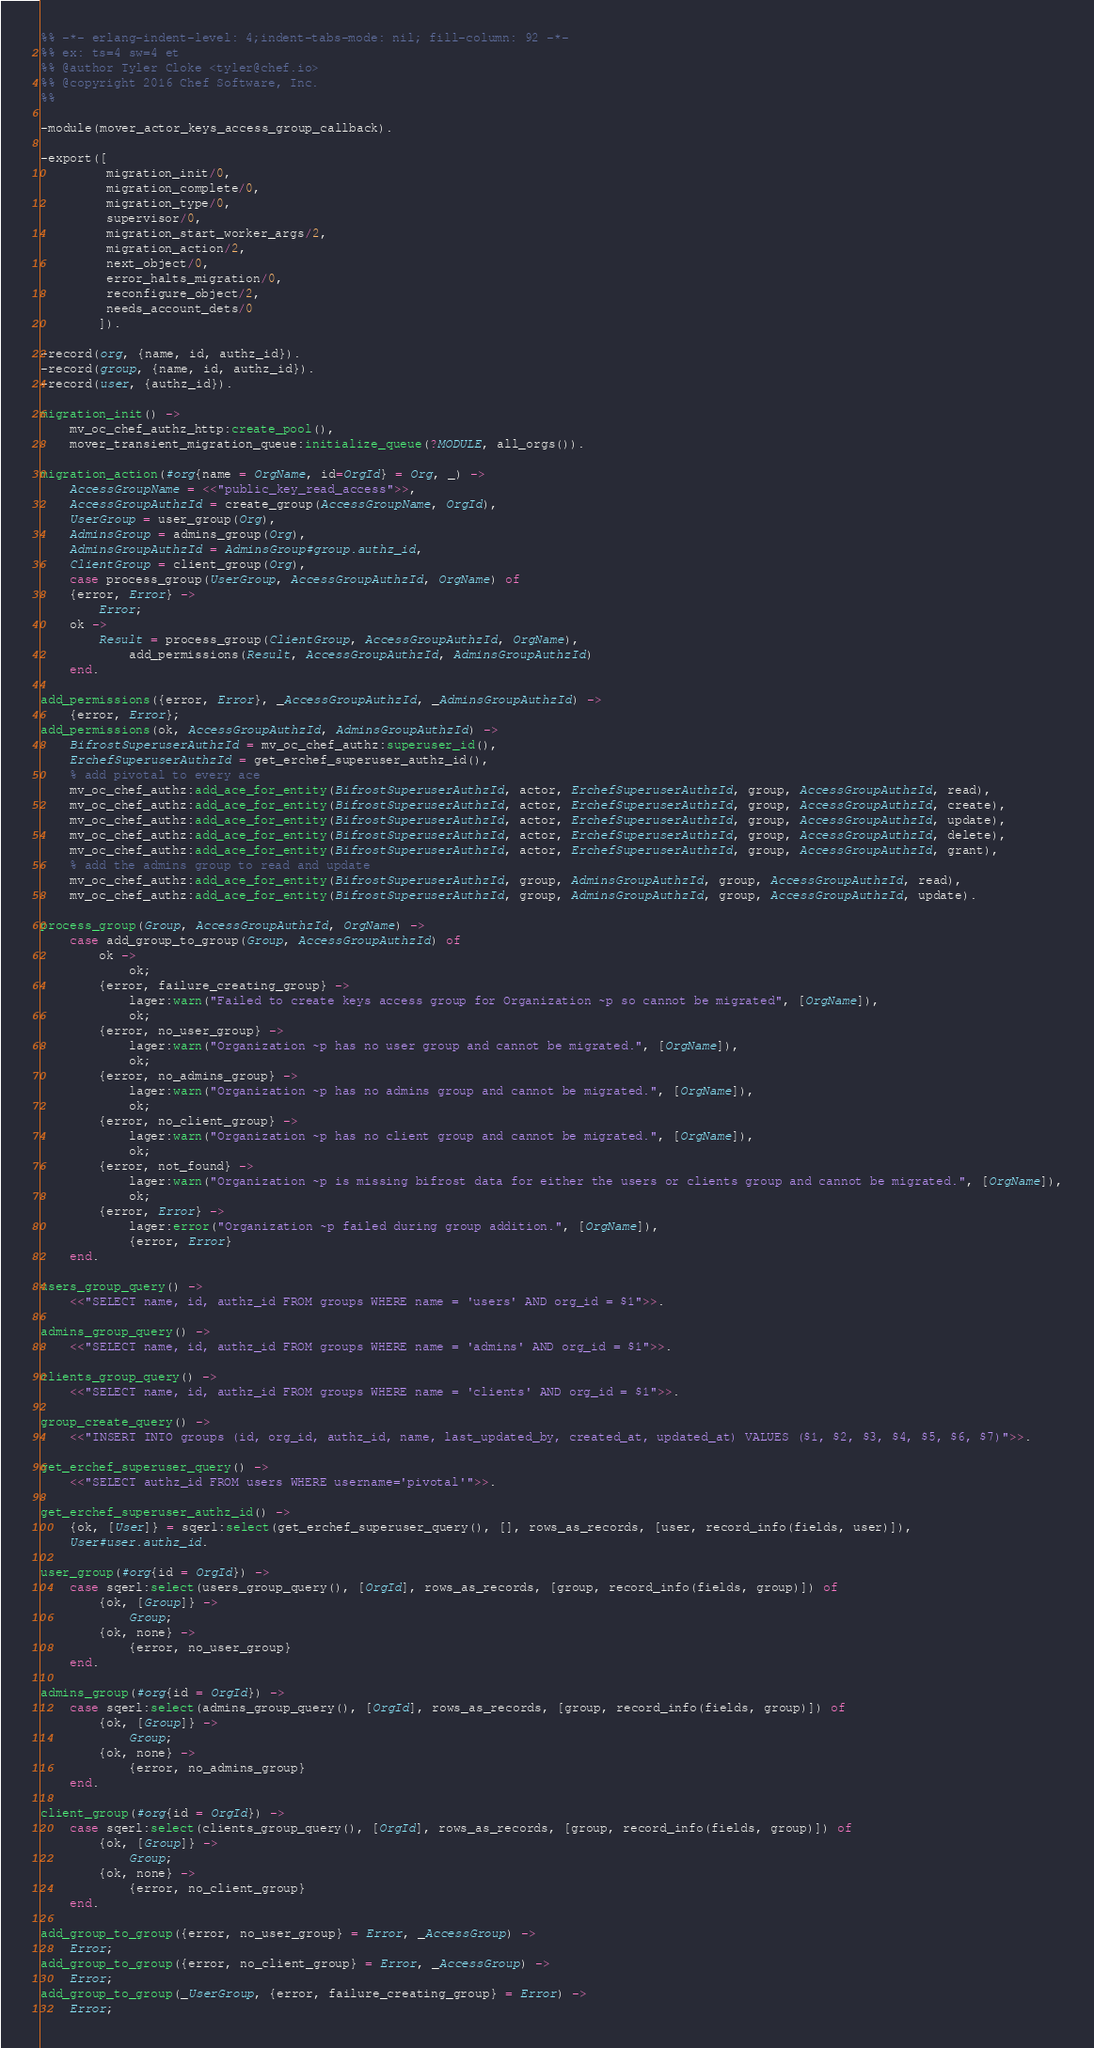<code> <loc_0><loc_0><loc_500><loc_500><_Erlang_>%% -*- erlang-indent-level: 4;indent-tabs-mode: nil; fill-column: 92 -*-
%% ex: ts=4 sw=4 et
%% @author Tyler Cloke <tyler@chef.io>
%% @copyright 2016 Chef Software, Inc.
%%

-module(mover_actor_keys_access_group_callback).

-export([
         migration_init/0,
         migration_complete/0,
         migration_type/0,
         supervisor/0,
         migration_start_worker_args/2,
         migration_action/2,
         next_object/0,
         error_halts_migration/0,
         reconfigure_object/2,
         needs_account_dets/0
        ]).

-record(org, {name, id, authz_id}).
-record(group, {name, id, authz_id}).
-record(user, {authz_id}).

migration_init() ->
    mv_oc_chef_authz_http:create_pool(),
    mover_transient_migration_queue:initialize_queue(?MODULE, all_orgs()).

migration_action(#org{name = OrgName, id=OrgId} = Org, _) ->
    AccessGroupName = <<"public_key_read_access">>,
    AccessGroupAuthzId = create_group(AccessGroupName, OrgId),
    UserGroup = user_group(Org),
    AdminsGroup = admins_group(Org),
    AdminsGroupAuthzId = AdminsGroup#group.authz_id,
    ClientGroup = client_group(Org),
    case process_group(UserGroup, AccessGroupAuthzId, OrgName) of
	{error, Error} ->
	    Error;
	ok ->
	    Result = process_group(ClientGroup, AccessGroupAuthzId, OrgName),
            add_permissions(Result, AccessGroupAuthzId, AdminsGroupAuthzId)
    end.

add_permissions({error, Error}, _AccessGroupAuthzId, _AdminsGroupAuthzId) ->
    {error, Error};
add_permissions(ok, AccessGroupAuthzId, AdminsGroupAuthzId) ->
    BifrostSuperuserAuthzId = mv_oc_chef_authz:superuser_id(),
    ErchefSuperuserAuthzId = get_erchef_superuser_authz_id(),
    % add pivotal to every ace
    mv_oc_chef_authz:add_ace_for_entity(BifrostSuperuserAuthzId, actor, ErchefSuperuserAuthzId, group, AccessGroupAuthzId, read),
    mv_oc_chef_authz:add_ace_for_entity(BifrostSuperuserAuthzId, actor, ErchefSuperuserAuthzId, group, AccessGroupAuthzId, create),
    mv_oc_chef_authz:add_ace_for_entity(BifrostSuperuserAuthzId, actor, ErchefSuperuserAuthzId, group, AccessGroupAuthzId, update),
    mv_oc_chef_authz:add_ace_for_entity(BifrostSuperuserAuthzId, actor, ErchefSuperuserAuthzId, group, AccessGroupAuthzId, delete),
    mv_oc_chef_authz:add_ace_for_entity(BifrostSuperuserAuthzId, actor, ErchefSuperuserAuthzId, group, AccessGroupAuthzId, grant),
    % add the admins group to read and update
    mv_oc_chef_authz:add_ace_for_entity(BifrostSuperuserAuthzId, group, AdminsGroupAuthzId, group, AccessGroupAuthzId, read),
    mv_oc_chef_authz:add_ace_for_entity(BifrostSuperuserAuthzId, group, AdminsGroupAuthzId, group, AccessGroupAuthzId, update).

process_group(Group, AccessGroupAuthzId, OrgName) ->
    case add_group_to_group(Group, AccessGroupAuthzId) of
        ok ->
            ok;
        {error, failure_creating_group} ->
            lager:warn("Failed to create keys access group for Organization ~p so cannot be migrated", [OrgName]),
            ok;
        {error, no_user_group} ->
            lager:warn("Organization ~p has no user group and cannot be migrated.", [OrgName]),
            ok;
        {error, no_admins_group} ->
            lager:warn("Organization ~p has no admins group and cannot be migrated.", [OrgName]),
            ok;
        {error, no_client_group} ->
            lager:warn("Organization ~p has no client group and cannot be migrated.", [OrgName]),
            ok;
        {error, not_found} ->
            lager:warn("Organization ~p is missing bifrost data for either the users or clients group and cannot be migrated.", [OrgName]),
            ok;
        {error, Error} ->
            lager:error("Organization ~p failed during group addition.", [OrgName]),
            {error, Error}
    end.

users_group_query() ->
    <<"SELECT name, id, authz_id FROM groups WHERE name = 'users' AND org_id = $1">>.

admins_group_query() ->
    <<"SELECT name, id, authz_id FROM groups WHERE name = 'admins' AND org_id = $1">>.

clients_group_query() ->
    <<"SELECT name, id, authz_id FROM groups WHERE name = 'clients' AND org_id = $1">>.

group_create_query() ->
    <<"INSERT INTO groups (id, org_id, authz_id, name, last_updated_by, created_at, updated_at) VALUES ($1, $2, $3, $4, $5, $6, $7)">>.

get_erchef_superuser_query() ->
    <<"SELECT authz_id FROM users WHERE username='pivotal'">>.

get_erchef_superuser_authz_id() ->
    {ok, [User]} = sqerl:select(get_erchef_superuser_query(), [], rows_as_records, [user, record_info(fields, user)]),
    User#user.authz_id.

user_group(#org{id = OrgId}) ->
    case sqerl:select(users_group_query(), [OrgId], rows_as_records, [group, record_info(fields, group)]) of
        {ok, [Group]} ->
            Group;
        {ok, none} ->
            {error, no_user_group}
    end.

admins_group(#org{id = OrgId}) ->
    case sqerl:select(admins_group_query(), [OrgId], rows_as_records, [group, record_info(fields, group)]) of
        {ok, [Group]} ->
            Group;
        {ok, none} ->
            {error, no_admins_group}
    end.

client_group(#org{id = OrgId}) ->
    case sqerl:select(clients_group_query(), [OrgId], rows_as_records, [group, record_info(fields, group)]) of
        {ok, [Group]} ->
            Group;
        {ok, none} ->
            {error, no_client_group}
    end.

add_group_to_group({error, no_user_group} = Error, _AccessGroup) ->
    Error;
add_group_to_group({error, no_client_group} = Error, _AccessGroup) ->
    Error;
add_group_to_group(_UserGroup, {error, failure_creating_group} = Error) ->
    Error;</code> 